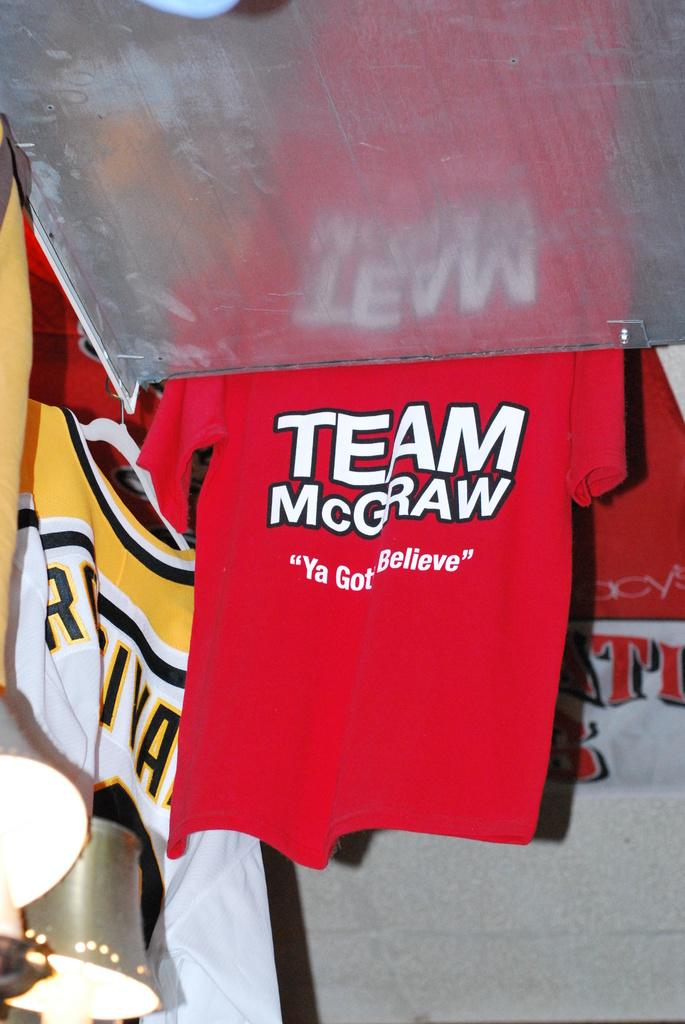<image>
Present a compact description of the photo's key features. A shirt advertising Team McGraw hangs up next to a metal plate. 